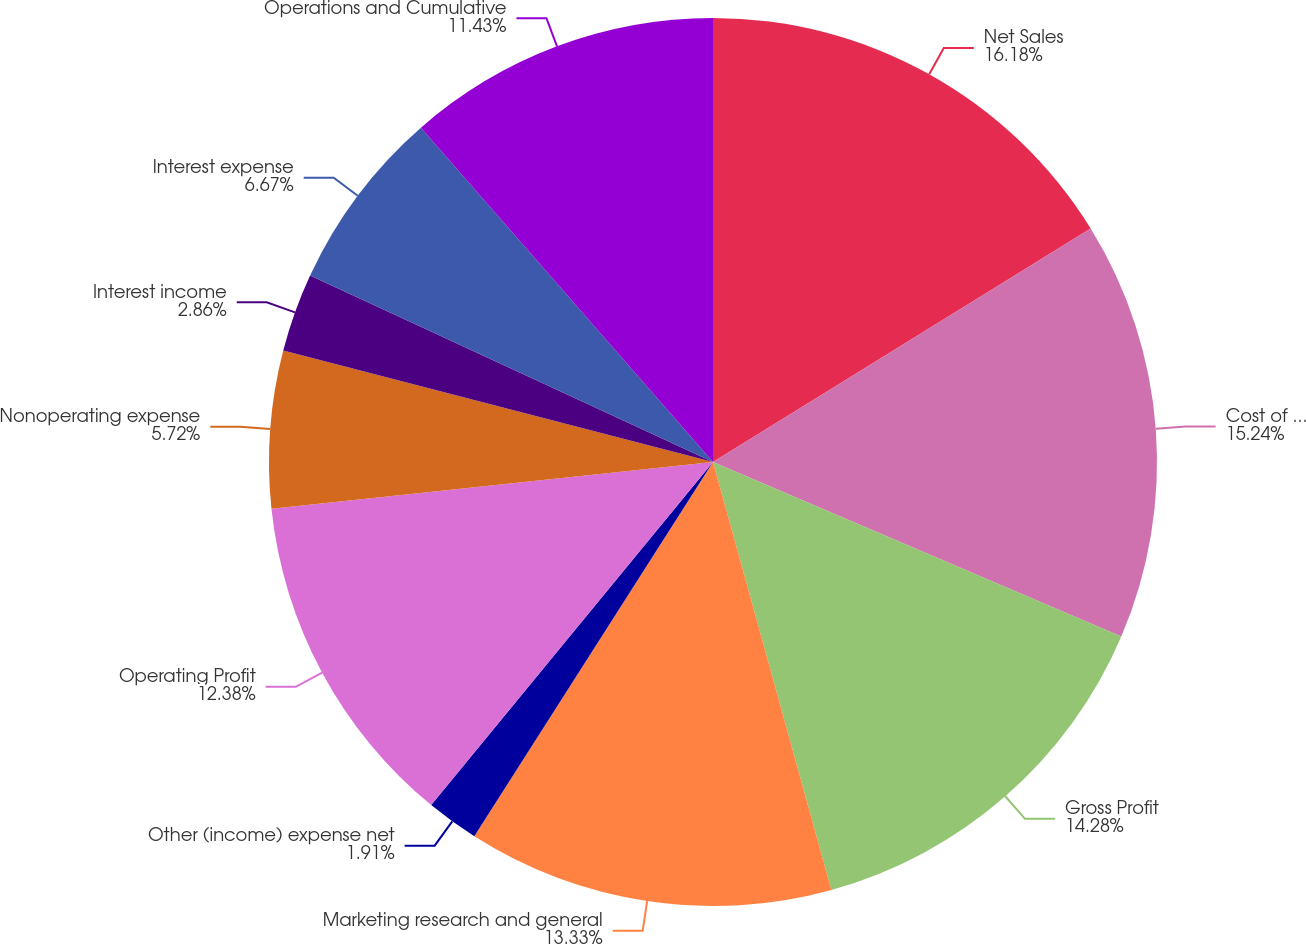Convert chart to OTSL. <chart><loc_0><loc_0><loc_500><loc_500><pie_chart><fcel>Net Sales<fcel>Cost of products sold<fcel>Gross Profit<fcel>Marketing research and general<fcel>Other (income) expense net<fcel>Operating Profit<fcel>Nonoperating expense<fcel>Interest income<fcel>Interest expense<fcel>Operations and Cumulative<nl><fcel>16.19%<fcel>15.24%<fcel>14.28%<fcel>13.33%<fcel>1.91%<fcel>12.38%<fcel>5.72%<fcel>2.86%<fcel>6.67%<fcel>11.43%<nl></chart> 